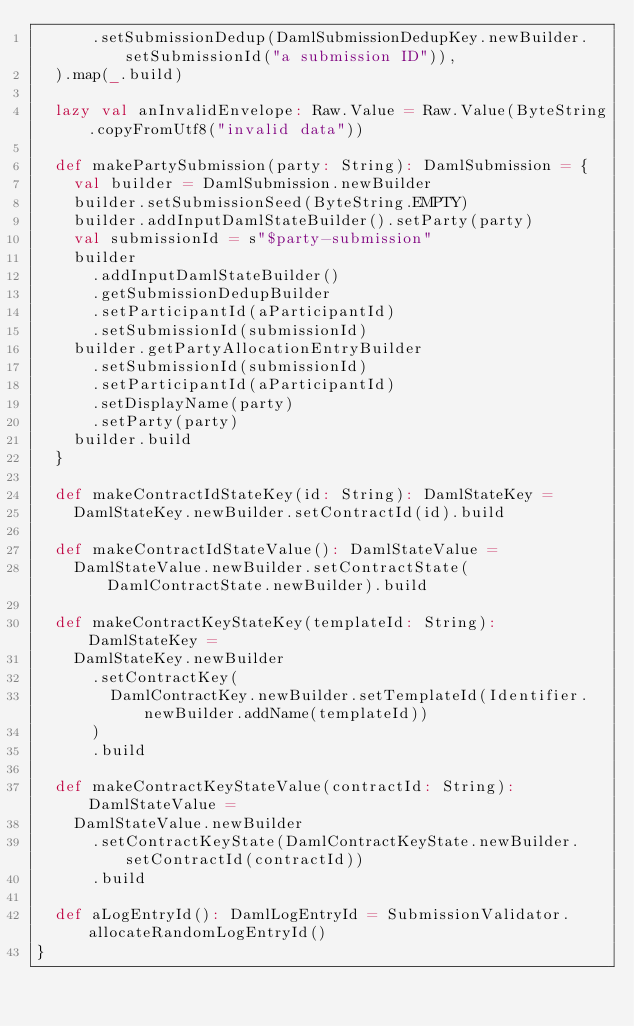<code> <loc_0><loc_0><loc_500><loc_500><_Scala_>      .setSubmissionDedup(DamlSubmissionDedupKey.newBuilder.setSubmissionId("a submission ID")),
  ).map(_.build)

  lazy val anInvalidEnvelope: Raw.Value = Raw.Value(ByteString.copyFromUtf8("invalid data"))

  def makePartySubmission(party: String): DamlSubmission = {
    val builder = DamlSubmission.newBuilder
    builder.setSubmissionSeed(ByteString.EMPTY)
    builder.addInputDamlStateBuilder().setParty(party)
    val submissionId = s"$party-submission"
    builder
      .addInputDamlStateBuilder()
      .getSubmissionDedupBuilder
      .setParticipantId(aParticipantId)
      .setSubmissionId(submissionId)
    builder.getPartyAllocationEntryBuilder
      .setSubmissionId(submissionId)
      .setParticipantId(aParticipantId)
      .setDisplayName(party)
      .setParty(party)
    builder.build
  }

  def makeContractIdStateKey(id: String): DamlStateKey =
    DamlStateKey.newBuilder.setContractId(id).build

  def makeContractIdStateValue(): DamlStateValue =
    DamlStateValue.newBuilder.setContractState(DamlContractState.newBuilder).build

  def makeContractKeyStateKey(templateId: String): DamlStateKey =
    DamlStateKey.newBuilder
      .setContractKey(
        DamlContractKey.newBuilder.setTemplateId(Identifier.newBuilder.addName(templateId))
      )
      .build

  def makeContractKeyStateValue(contractId: String): DamlStateValue =
    DamlStateValue.newBuilder
      .setContractKeyState(DamlContractKeyState.newBuilder.setContractId(contractId))
      .build

  def aLogEntryId(): DamlLogEntryId = SubmissionValidator.allocateRandomLogEntryId()
}
</code> 